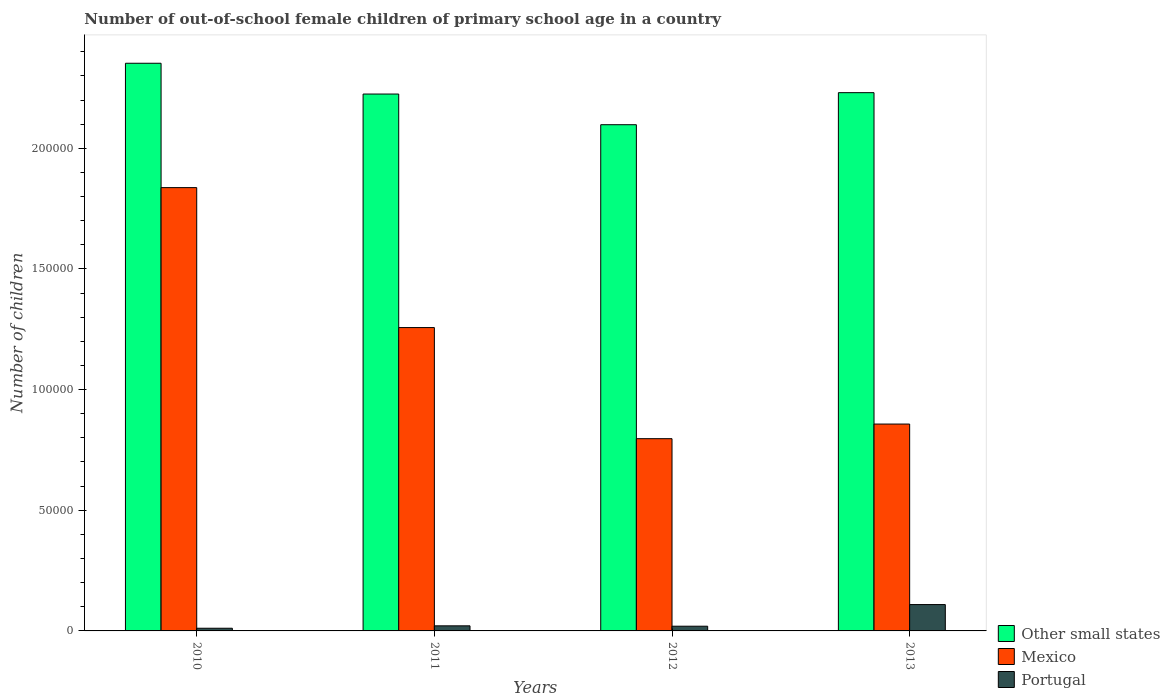How many different coloured bars are there?
Offer a terse response. 3. Are the number of bars per tick equal to the number of legend labels?
Ensure brevity in your answer.  Yes. How many bars are there on the 4th tick from the left?
Provide a succinct answer. 3. How many bars are there on the 1st tick from the right?
Give a very brief answer. 3. In how many cases, is the number of bars for a given year not equal to the number of legend labels?
Your response must be concise. 0. What is the number of out-of-school female children in Mexico in 2012?
Offer a terse response. 7.97e+04. Across all years, what is the maximum number of out-of-school female children in Other small states?
Your response must be concise. 2.35e+05. Across all years, what is the minimum number of out-of-school female children in Mexico?
Offer a terse response. 7.97e+04. What is the total number of out-of-school female children in Other small states in the graph?
Offer a terse response. 8.91e+05. What is the difference between the number of out-of-school female children in Other small states in 2012 and that in 2013?
Offer a very short reply. -1.33e+04. What is the difference between the number of out-of-school female children in Other small states in 2012 and the number of out-of-school female children in Mexico in 2013?
Ensure brevity in your answer.  1.24e+05. What is the average number of out-of-school female children in Other small states per year?
Ensure brevity in your answer.  2.23e+05. In the year 2013, what is the difference between the number of out-of-school female children in Mexico and number of out-of-school female children in Portugal?
Offer a very short reply. 7.48e+04. What is the ratio of the number of out-of-school female children in Portugal in 2012 to that in 2013?
Offer a very short reply. 0.18. What is the difference between the highest and the second highest number of out-of-school female children in Portugal?
Offer a very short reply. 8814. What is the difference between the highest and the lowest number of out-of-school female children in Portugal?
Provide a short and direct response. 9809. In how many years, is the number of out-of-school female children in Mexico greater than the average number of out-of-school female children in Mexico taken over all years?
Give a very brief answer. 2. Is the sum of the number of out-of-school female children in Other small states in 2011 and 2012 greater than the maximum number of out-of-school female children in Portugal across all years?
Provide a short and direct response. Yes. What does the 3rd bar from the left in 2011 represents?
Your answer should be compact. Portugal. What does the 1st bar from the right in 2013 represents?
Your response must be concise. Portugal. Is it the case that in every year, the sum of the number of out-of-school female children in Mexico and number of out-of-school female children in Other small states is greater than the number of out-of-school female children in Portugal?
Give a very brief answer. Yes. Where does the legend appear in the graph?
Your response must be concise. Bottom right. How are the legend labels stacked?
Keep it short and to the point. Vertical. What is the title of the graph?
Make the answer very short. Number of out-of-school female children of primary school age in a country. What is the label or title of the X-axis?
Your response must be concise. Years. What is the label or title of the Y-axis?
Give a very brief answer. Number of children. What is the Number of children of Other small states in 2010?
Your answer should be compact. 2.35e+05. What is the Number of children in Mexico in 2010?
Ensure brevity in your answer.  1.84e+05. What is the Number of children of Portugal in 2010?
Give a very brief answer. 1113. What is the Number of children of Other small states in 2011?
Offer a very short reply. 2.22e+05. What is the Number of children in Mexico in 2011?
Provide a short and direct response. 1.26e+05. What is the Number of children of Portugal in 2011?
Make the answer very short. 2108. What is the Number of children in Other small states in 2012?
Your answer should be compact. 2.10e+05. What is the Number of children of Mexico in 2012?
Give a very brief answer. 7.97e+04. What is the Number of children in Portugal in 2012?
Provide a short and direct response. 1949. What is the Number of children of Other small states in 2013?
Make the answer very short. 2.23e+05. What is the Number of children of Mexico in 2013?
Give a very brief answer. 8.57e+04. What is the Number of children in Portugal in 2013?
Make the answer very short. 1.09e+04. Across all years, what is the maximum Number of children in Other small states?
Your answer should be compact. 2.35e+05. Across all years, what is the maximum Number of children in Mexico?
Ensure brevity in your answer.  1.84e+05. Across all years, what is the maximum Number of children of Portugal?
Provide a short and direct response. 1.09e+04. Across all years, what is the minimum Number of children of Other small states?
Provide a short and direct response. 2.10e+05. Across all years, what is the minimum Number of children in Mexico?
Provide a short and direct response. 7.97e+04. Across all years, what is the minimum Number of children of Portugal?
Keep it short and to the point. 1113. What is the total Number of children of Other small states in the graph?
Your response must be concise. 8.91e+05. What is the total Number of children in Mexico in the graph?
Provide a succinct answer. 4.75e+05. What is the total Number of children of Portugal in the graph?
Provide a short and direct response. 1.61e+04. What is the difference between the Number of children of Other small states in 2010 and that in 2011?
Your response must be concise. 1.28e+04. What is the difference between the Number of children of Mexico in 2010 and that in 2011?
Your answer should be compact. 5.80e+04. What is the difference between the Number of children in Portugal in 2010 and that in 2011?
Your answer should be compact. -995. What is the difference between the Number of children of Other small states in 2010 and that in 2012?
Provide a short and direct response. 2.55e+04. What is the difference between the Number of children in Mexico in 2010 and that in 2012?
Make the answer very short. 1.04e+05. What is the difference between the Number of children of Portugal in 2010 and that in 2012?
Offer a very short reply. -836. What is the difference between the Number of children of Other small states in 2010 and that in 2013?
Provide a succinct answer. 1.22e+04. What is the difference between the Number of children of Mexico in 2010 and that in 2013?
Give a very brief answer. 9.80e+04. What is the difference between the Number of children of Portugal in 2010 and that in 2013?
Offer a very short reply. -9809. What is the difference between the Number of children of Other small states in 2011 and that in 2012?
Make the answer very short. 1.27e+04. What is the difference between the Number of children in Mexico in 2011 and that in 2012?
Keep it short and to the point. 4.60e+04. What is the difference between the Number of children of Portugal in 2011 and that in 2012?
Your response must be concise. 159. What is the difference between the Number of children of Other small states in 2011 and that in 2013?
Keep it short and to the point. -569. What is the difference between the Number of children of Mexico in 2011 and that in 2013?
Your response must be concise. 4.00e+04. What is the difference between the Number of children of Portugal in 2011 and that in 2013?
Provide a short and direct response. -8814. What is the difference between the Number of children in Other small states in 2012 and that in 2013?
Your response must be concise. -1.33e+04. What is the difference between the Number of children of Mexico in 2012 and that in 2013?
Make the answer very short. -6056. What is the difference between the Number of children in Portugal in 2012 and that in 2013?
Offer a very short reply. -8973. What is the difference between the Number of children in Other small states in 2010 and the Number of children in Mexico in 2011?
Your answer should be very brief. 1.10e+05. What is the difference between the Number of children of Other small states in 2010 and the Number of children of Portugal in 2011?
Your answer should be compact. 2.33e+05. What is the difference between the Number of children in Mexico in 2010 and the Number of children in Portugal in 2011?
Your answer should be compact. 1.82e+05. What is the difference between the Number of children in Other small states in 2010 and the Number of children in Mexico in 2012?
Offer a very short reply. 1.56e+05. What is the difference between the Number of children in Other small states in 2010 and the Number of children in Portugal in 2012?
Offer a very short reply. 2.33e+05. What is the difference between the Number of children of Mexico in 2010 and the Number of children of Portugal in 2012?
Provide a short and direct response. 1.82e+05. What is the difference between the Number of children in Other small states in 2010 and the Number of children in Mexico in 2013?
Provide a short and direct response. 1.50e+05. What is the difference between the Number of children of Other small states in 2010 and the Number of children of Portugal in 2013?
Your response must be concise. 2.24e+05. What is the difference between the Number of children of Mexico in 2010 and the Number of children of Portugal in 2013?
Your answer should be very brief. 1.73e+05. What is the difference between the Number of children in Other small states in 2011 and the Number of children in Mexico in 2012?
Ensure brevity in your answer.  1.43e+05. What is the difference between the Number of children of Other small states in 2011 and the Number of children of Portugal in 2012?
Ensure brevity in your answer.  2.21e+05. What is the difference between the Number of children in Mexico in 2011 and the Number of children in Portugal in 2012?
Offer a terse response. 1.24e+05. What is the difference between the Number of children in Other small states in 2011 and the Number of children in Mexico in 2013?
Provide a short and direct response. 1.37e+05. What is the difference between the Number of children of Other small states in 2011 and the Number of children of Portugal in 2013?
Keep it short and to the point. 2.12e+05. What is the difference between the Number of children of Mexico in 2011 and the Number of children of Portugal in 2013?
Your answer should be very brief. 1.15e+05. What is the difference between the Number of children of Other small states in 2012 and the Number of children of Mexico in 2013?
Offer a terse response. 1.24e+05. What is the difference between the Number of children in Other small states in 2012 and the Number of children in Portugal in 2013?
Your response must be concise. 1.99e+05. What is the difference between the Number of children in Mexico in 2012 and the Number of children in Portugal in 2013?
Keep it short and to the point. 6.87e+04. What is the average Number of children in Other small states per year?
Your answer should be very brief. 2.23e+05. What is the average Number of children of Mexico per year?
Give a very brief answer. 1.19e+05. What is the average Number of children of Portugal per year?
Provide a succinct answer. 4023. In the year 2010, what is the difference between the Number of children in Other small states and Number of children in Mexico?
Provide a succinct answer. 5.15e+04. In the year 2010, what is the difference between the Number of children of Other small states and Number of children of Portugal?
Your answer should be very brief. 2.34e+05. In the year 2010, what is the difference between the Number of children of Mexico and Number of children of Portugal?
Give a very brief answer. 1.83e+05. In the year 2011, what is the difference between the Number of children of Other small states and Number of children of Mexico?
Offer a terse response. 9.68e+04. In the year 2011, what is the difference between the Number of children of Other small states and Number of children of Portugal?
Offer a very short reply. 2.20e+05. In the year 2011, what is the difference between the Number of children of Mexico and Number of children of Portugal?
Make the answer very short. 1.24e+05. In the year 2012, what is the difference between the Number of children of Other small states and Number of children of Mexico?
Offer a very short reply. 1.30e+05. In the year 2012, what is the difference between the Number of children in Other small states and Number of children in Portugal?
Your answer should be very brief. 2.08e+05. In the year 2012, what is the difference between the Number of children in Mexico and Number of children in Portugal?
Offer a very short reply. 7.77e+04. In the year 2013, what is the difference between the Number of children in Other small states and Number of children in Mexico?
Provide a short and direct response. 1.37e+05. In the year 2013, what is the difference between the Number of children in Other small states and Number of children in Portugal?
Provide a succinct answer. 2.12e+05. In the year 2013, what is the difference between the Number of children in Mexico and Number of children in Portugal?
Make the answer very short. 7.48e+04. What is the ratio of the Number of children of Other small states in 2010 to that in 2011?
Provide a succinct answer. 1.06. What is the ratio of the Number of children of Mexico in 2010 to that in 2011?
Your answer should be compact. 1.46. What is the ratio of the Number of children in Portugal in 2010 to that in 2011?
Your answer should be compact. 0.53. What is the ratio of the Number of children in Other small states in 2010 to that in 2012?
Your response must be concise. 1.12. What is the ratio of the Number of children in Mexico in 2010 to that in 2012?
Ensure brevity in your answer.  2.31. What is the ratio of the Number of children of Portugal in 2010 to that in 2012?
Provide a succinct answer. 0.57. What is the ratio of the Number of children of Other small states in 2010 to that in 2013?
Your answer should be very brief. 1.05. What is the ratio of the Number of children in Mexico in 2010 to that in 2013?
Your answer should be compact. 2.14. What is the ratio of the Number of children of Portugal in 2010 to that in 2013?
Offer a very short reply. 0.1. What is the ratio of the Number of children of Other small states in 2011 to that in 2012?
Make the answer very short. 1.06. What is the ratio of the Number of children of Mexico in 2011 to that in 2012?
Offer a very short reply. 1.58. What is the ratio of the Number of children in Portugal in 2011 to that in 2012?
Give a very brief answer. 1.08. What is the ratio of the Number of children of Other small states in 2011 to that in 2013?
Your response must be concise. 1. What is the ratio of the Number of children of Mexico in 2011 to that in 2013?
Provide a short and direct response. 1.47. What is the ratio of the Number of children of Portugal in 2011 to that in 2013?
Keep it short and to the point. 0.19. What is the ratio of the Number of children of Other small states in 2012 to that in 2013?
Provide a succinct answer. 0.94. What is the ratio of the Number of children of Mexico in 2012 to that in 2013?
Give a very brief answer. 0.93. What is the ratio of the Number of children in Portugal in 2012 to that in 2013?
Provide a short and direct response. 0.18. What is the difference between the highest and the second highest Number of children of Other small states?
Your answer should be very brief. 1.22e+04. What is the difference between the highest and the second highest Number of children in Mexico?
Make the answer very short. 5.80e+04. What is the difference between the highest and the second highest Number of children of Portugal?
Provide a short and direct response. 8814. What is the difference between the highest and the lowest Number of children of Other small states?
Provide a short and direct response. 2.55e+04. What is the difference between the highest and the lowest Number of children of Mexico?
Your answer should be compact. 1.04e+05. What is the difference between the highest and the lowest Number of children of Portugal?
Offer a very short reply. 9809. 